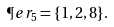<formula> <loc_0><loc_0><loc_500><loc_500>\P e r _ { 5 } = \{ 1 , 2 , 8 \} .</formula> 